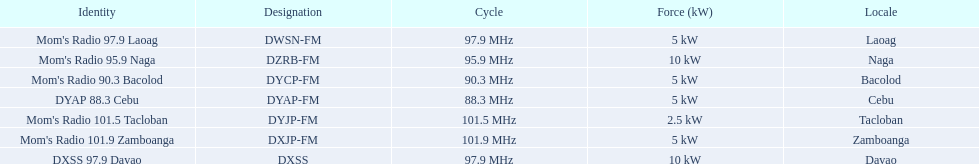What are the frequencies for radios of dyap-fm? 97.9 MHz, 95.9 MHz, 90.3 MHz, 88.3 MHz, 101.5 MHz, 101.9 MHz, 97.9 MHz. What is the lowest frequency? 88.3 MHz. Which radio has this frequency? DYAP 88.3 Cebu. 